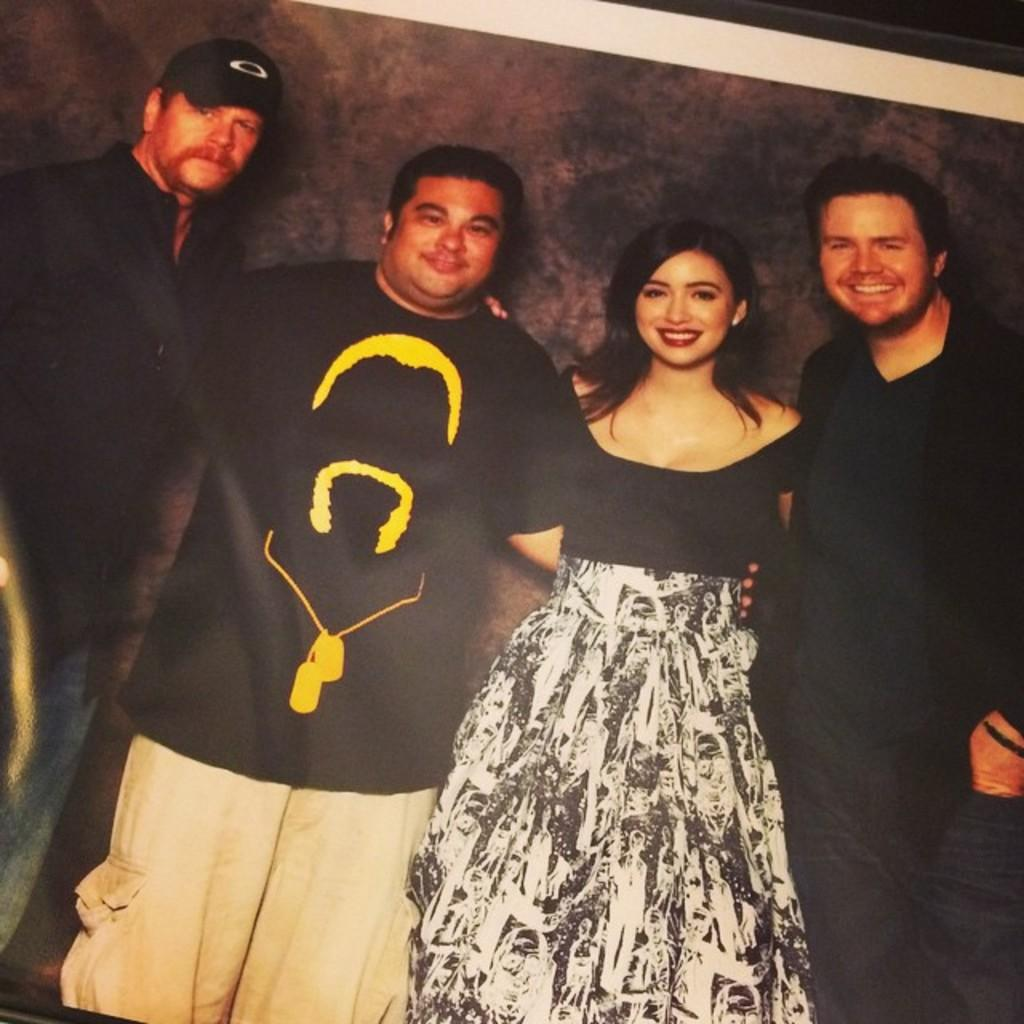What is the subject of the image? The image is a photograph of a photograph. How many people are in the inner photograph? There are three people in the inner photograph. Can you describe the gender of the people in the inner photograph? Two of the people are men, and one is a woman. What are the people in the inner photograph doing? The three people are standing and posing for the picture. How many eyes can be seen on the stick in the image? There is no stick or eyes present in the image. 